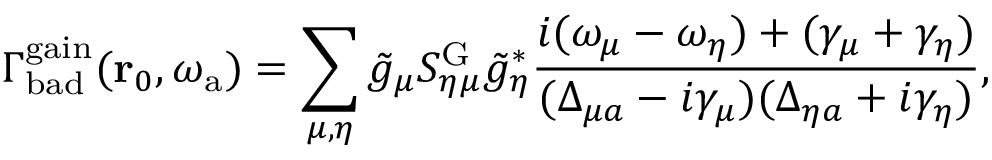Convert formula to latex. <formula><loc_0><loc_0><loc_500><loc_500>\Gamma _ { b a d } ^ { g a i n } ( r _ { 0 } , \omega _ { a } ) = \sum _ { \mu , \eta } \tilde { g } _ { \mu } S _ { \eta \mu } ^ { G } \tilde { g } _ { \eta } ^ { * } \frac { i ( \omega _ { \mu } - \omega _ { \eta } ) + ( \gamma _ { \mu } + \gamma _ { \eta } ) } { ( \Delta _ { \mu a } - i \gamma _ { \mu } ) ( \Delta _ { \eta a } + i \gamma _ { \eta } ) } ,</formula> 